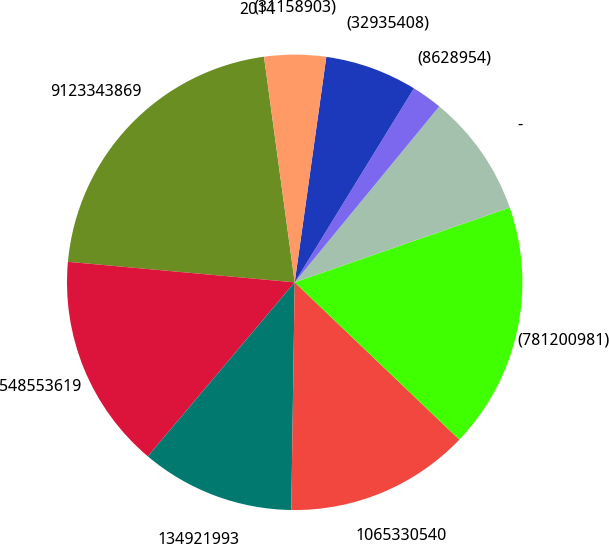<chart> <loc_0><loc_0><loc_500><loc_500><pie_chart><fcel>2014<fcel>9123343869<fcel>548553619<fcel>134921993<fcel>1065330540<fcel>(781200981)<fcel>-<fcel>(8628954)<fcel>(32935408)<fcel>(31158903)<nl><fcel>0.0%<fcel>21.41%<fcel>15.28%<fcel>10.92%<fcel>13.1%<fcel>17.46%<fcel>8.73%<fcel>2.18%<fcel>6.55%<fcel>4.37%<nl></chart> 